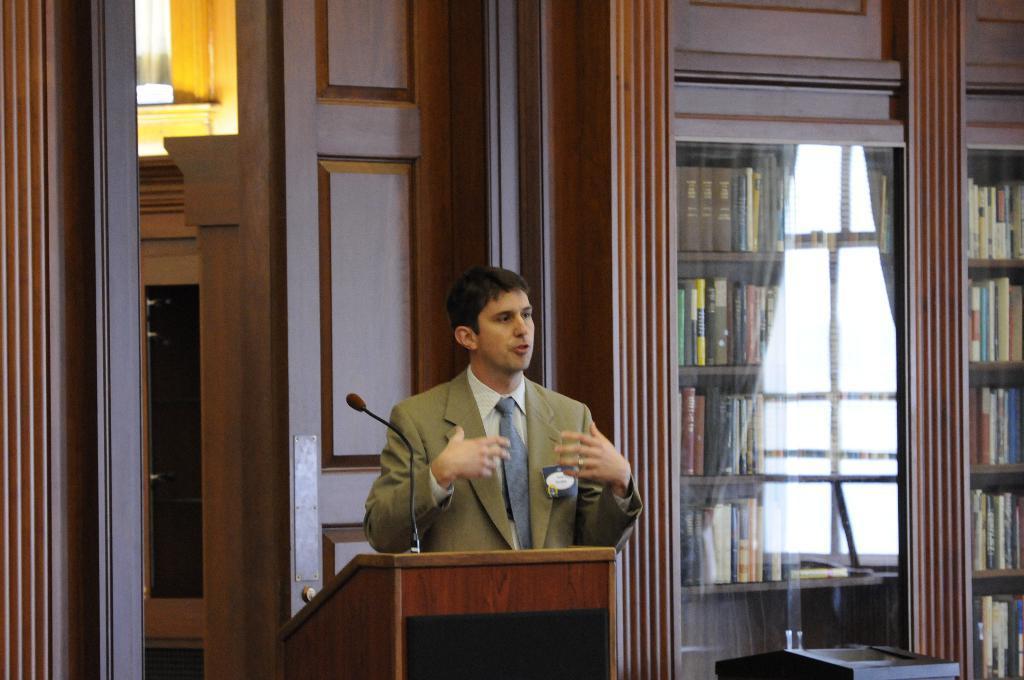Can you describe this image briefly? In the picture we can see a man standing near the table and explaining something, he is wearing a green blazer, with tie and shirt, In the background we can see a door, wall which is with wooden and some racks beside to to it, in the racks we can see many books. 